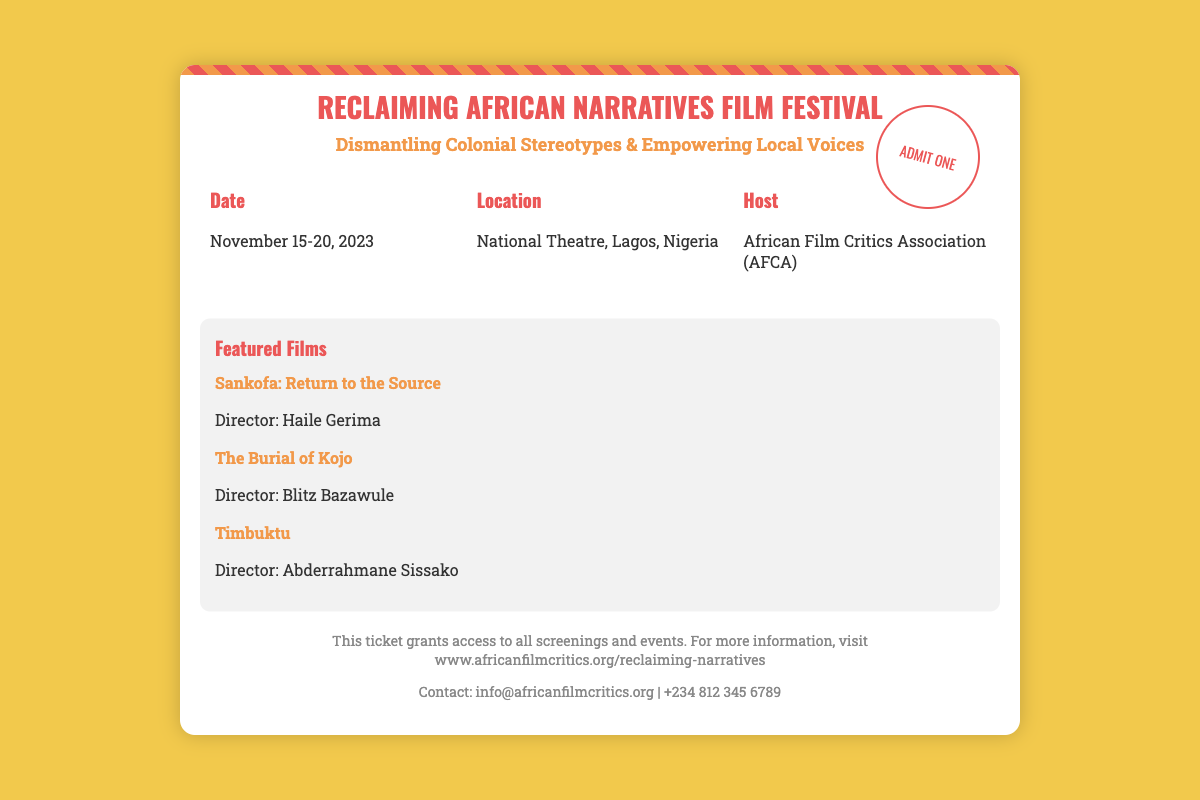what is the title of the film festival? The title of the festival is prominently displayed at the top of the ticket.
Answer: Reclaiming African Narratives Film Festival what are the festival dates? The festival dates are listed in the details section of the ticket.
Answer: November 15-20, 2023 where is the festival located? The location of the festival is included in the details section of the ticket.
Answer: National Theatre, Lagos, Nigeria who is hosting the festival? The host organization for the festival is mentioned in the details section.
Answer: African Film Critics Association (AFCA) how many featured films are listed? The number of featured films can be counted in the featured films section of the ticket.
Answer: Three what is the name of the director of "Timbuktu"? The ticket specifies the director of the film "Timbuktu" in the featured films section.
Answer: Abderrahmane Sissako what is the main theme of the festival? The main theme of the festival is introduced in the subtitle of the ticket.
Answer: Dismantling Colonial Stereotypes & Empowering Local Voices what type of access does this ticket grant? The footer mentions the access granted by the ticket.
Answer: All screenings and events how can attendees get more information? The footer provides a way for attendees to get additional information.
Answer: www.africanfilmcritics.org/reclaiming-narratives 